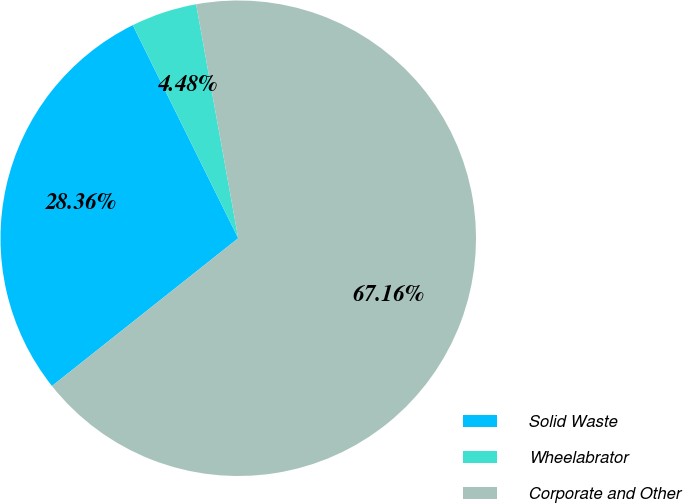Convert chart to OTSL. <chart><loc_0><loc_0><loc_500><loc_500><pie_chart><fcel>Solid Waste<fcel>Wheelabrator<fcel>Corporate and Other<nl><fcel>28.36%<fcel>4.48%<fcel>67.16%<nl></chart> 